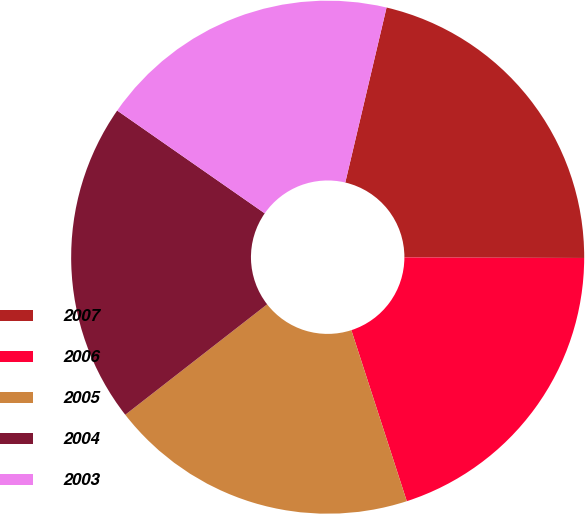<chart> <loc_0><loc_0><loc_500><loc_500><pie_chart><fcel>2007<fcel>2006<fcel>2005<fcel>2004<fcel>2003<nl><fcel>21.36%<fcel>19.96%<fcel>19.46%<fcel>20.21%<fcel>19.0%<nl></chart> 